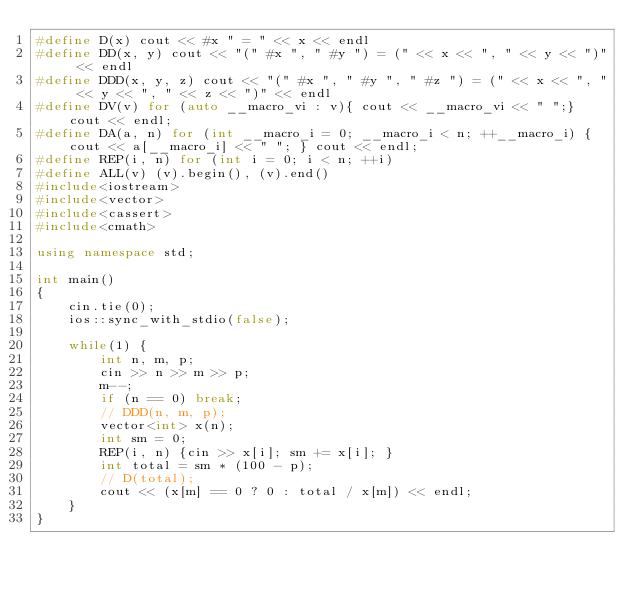<code> <loc_0><loc_0><loc_500><loc_500><_C++_>#define D(x) cout << #x " = " << x << endl
#define DD(x, y) cout << "(" #x ", " #y ") = (" << x << ", " << y << ")" << endl
#define DDD(x, y, z) cout << "(" #x ", " #y ", " #z ") = (" << x << ", " << y << ", " << z << ")" << endl
#define DV(v) for (auto __macro_vi : v){ cout << __macro_vi << " ";} cout << endl;
#define DA(a, n) for (int __macro_i = 0; __macro_i < n; ++__macro_i) { cout << a[__macro_i] << " "; } cout << endl;
#define REP(i, n) for (int i = 0; i < n; ++i)
#define ALL(v) (v).begin(), (v).end()
#include<iostream>
#include<vector>
#include<cassert>
#include<cmath>

using namespace std;

int main()
{
    cin.tie(0);
    ios::sync_with_stdio(false);

    while(1) {
        int n, m, p;
        cin >> n >> m >> p;
        m--;
        if (n == 0) break;
        // DDD(n, m, p);
        vector<int> x(n);
        int sm = 0;
        REP(i, n) {cin >> x[i]; sm += x[i]; }
        int total = sm * (100 - p);
        // D(total);
        cout << (x[m] == 0 ? 0 : total / x[m]) << endl;
    }
}

</code> 